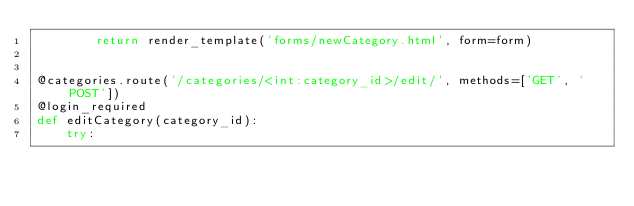Convert code to text. <code><loc_0><loc_0><loc_500><loc_500><_Python_>        return render_template('forms/newCategory.html', form=form)


@categories.route('/categories/<int:category_id>/edit/', methods=['GET', 'POST'])
@login_required
def editCategory(category_id):
    try:</code> 